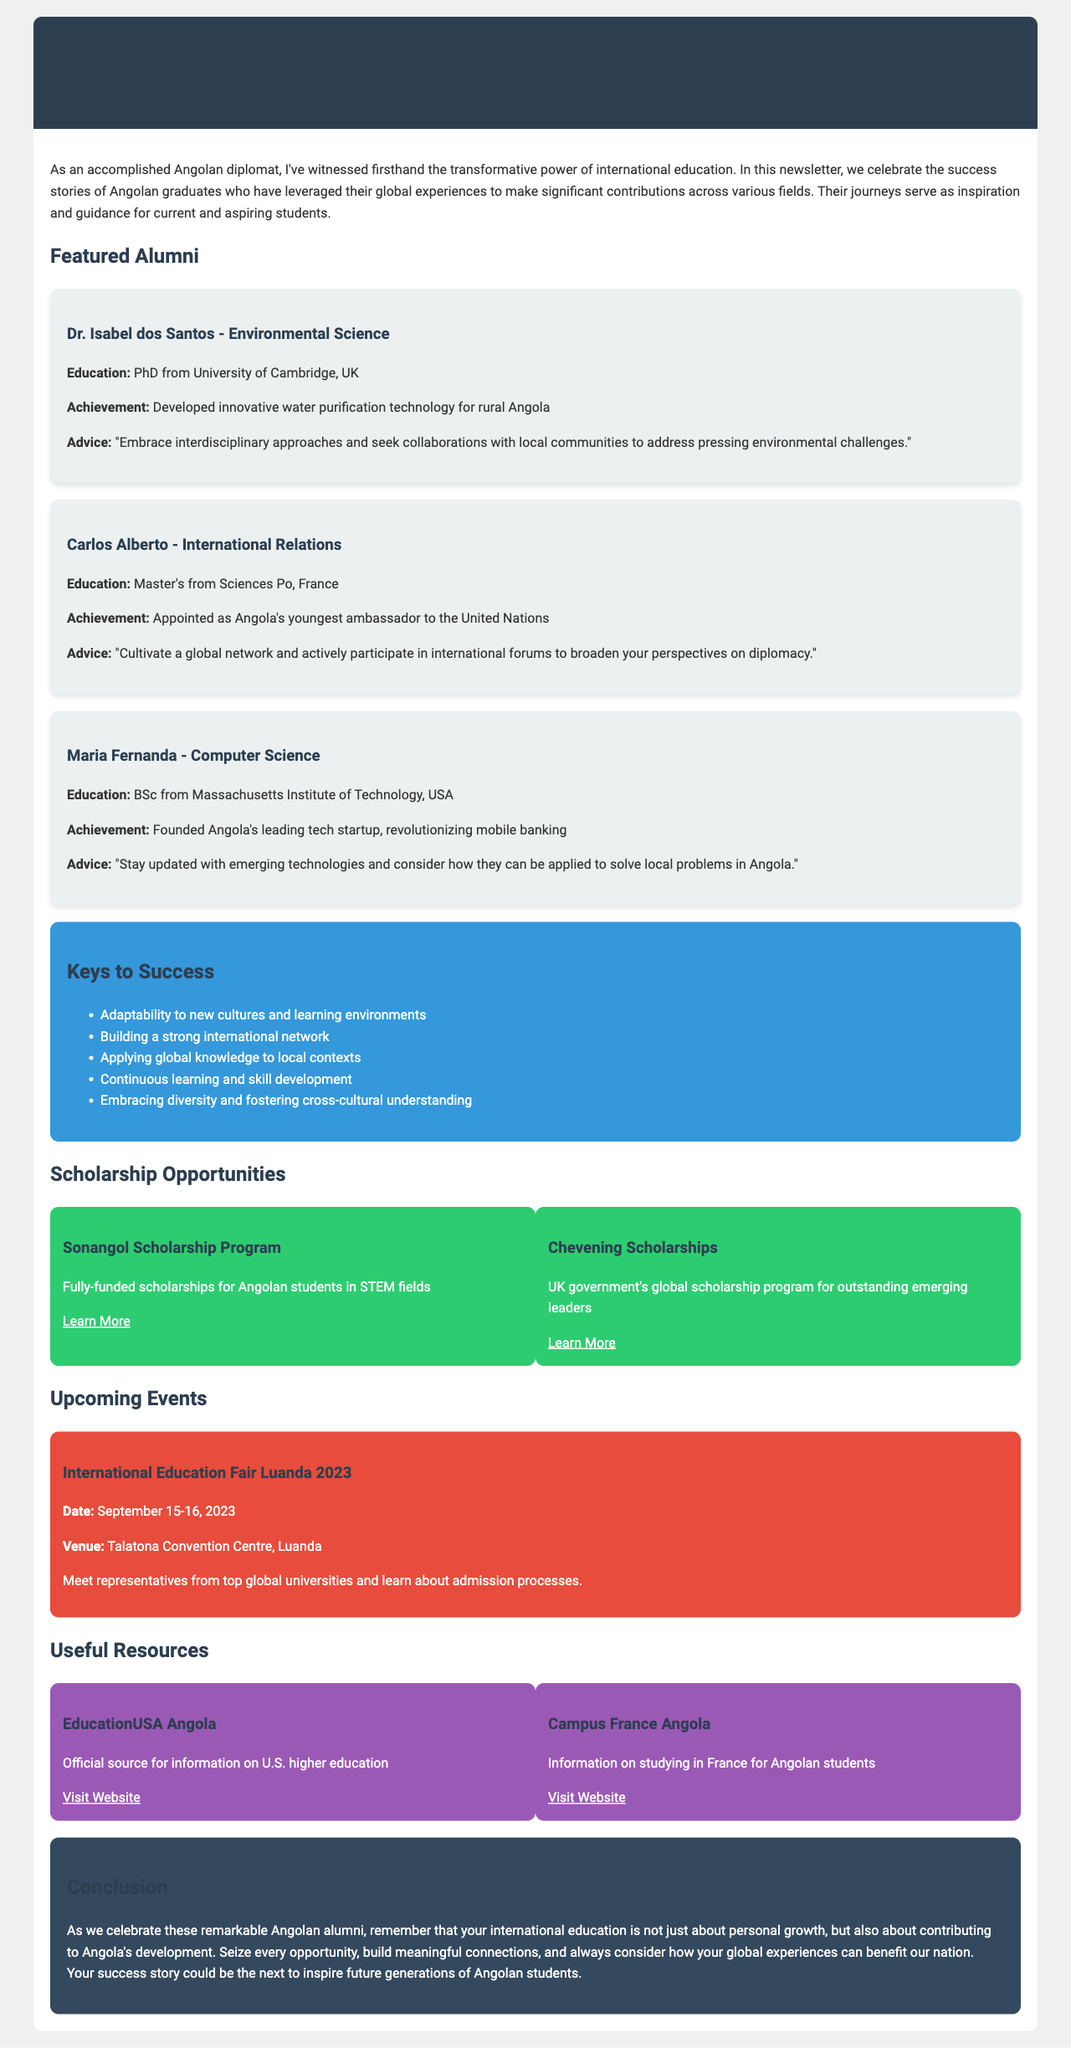What is the title of the newsletter? The title is found at the top of the document, representing the main theme.
Answer: Angolan Global Achievers: Inspiring Stories of International Education Who is featured in the field of Environmental Science? The document lists notable alumni and their respective fields, including their names and achievements.
Answer: Dr. Isabel dos Santos What achievement did Carlos Alberto accomplish? The achievement is specified under each featured alumnus, summarizing their significant contributions.
Answer: Appointed as Angola's youngest ambassador to the United Nations What scholarship program is mentioned for STEM fields? The document names scholarship opportunities that would support students in specific areas.
Answer: Sonangol Scholarship Program When is the International Education Fair Luanda 2023 scheduled? The event details include the name and date, providing specific information for prospective attendees.
Answer: September 15-16, 2023 How many success factors are listed in the newsletter? The number of listed success factors reflects the range of elements important for alumni success in international education.
Answer: Five What advice does Maria Fernanda give to current students? Each featured alumnus provides advice, which is crucial for current students looking to follow similar paths.
Answer: Stay updated with emerging technologies and consider how they can be applied to solve local problems in Angola What is the purpose of the conclusion section? The conclusion wraps up the themes of the newsletter, focusing on the intended message for readers.
Answer: To inspire future generations of Angolan students 